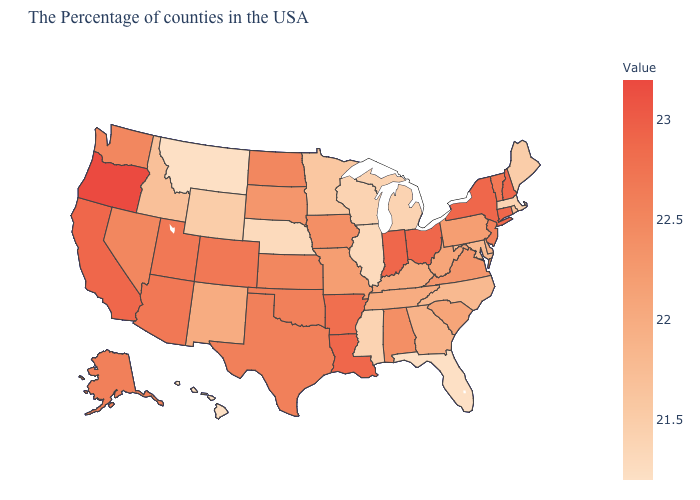Does Tennessee have the lowest value in the USA?
Concise answer only. No. Which states hav the highest value in the MidWest?
Quick response, please. Ohio, Indiana. Does Montana have the lowest value in the USA?
Quick response, please. Yes. Is the legend a continuous bar?
Answer briefly. Yes. Is the legend a continuous bar?
Give a very brief answer. Yes. Does Maryland have the lowest value in the South?
Write a very short answer. No. 